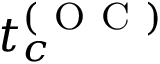<formula> <loc_0><loc_0><loc_500><loc_500>t _ { c } ^ { ( O C ) }</formula> 